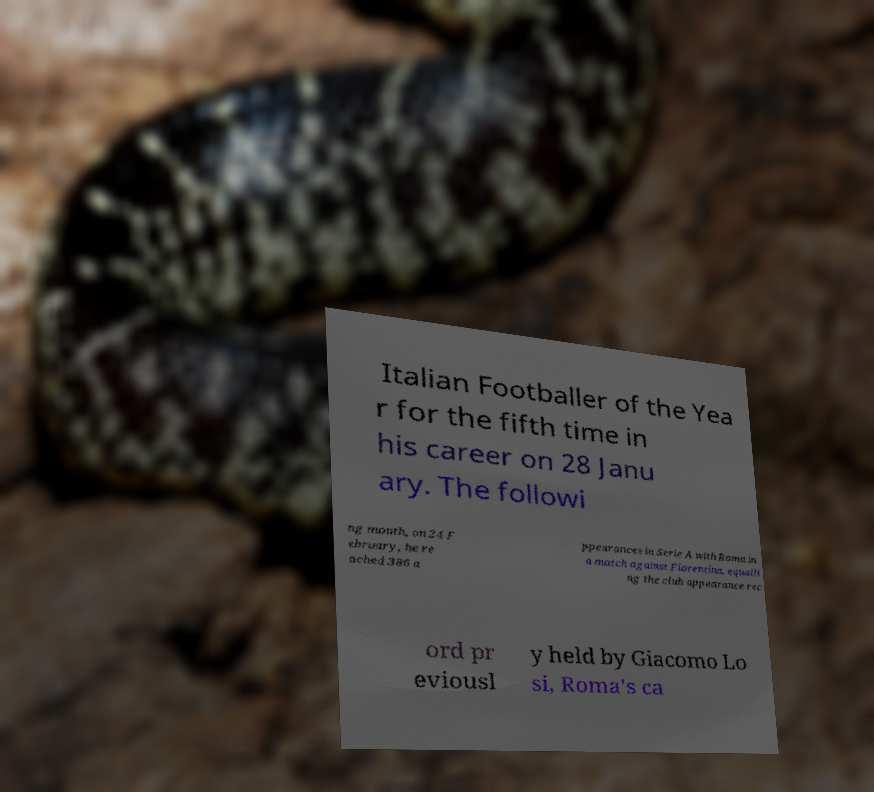What messages or text are displayed in this image? I need them in a readable, typed format. Italian Footballer of the Yea r for the fifth time in his career on 28 Janu ary. The followi ng month, on 24 F ebruary, he re ached 386 a ppearances in Serie A with Roma in a match against Fiorentina, equalli ng the club appearance rec ord pr eviousl y held by Giacomo Lo si, Roma's ca 